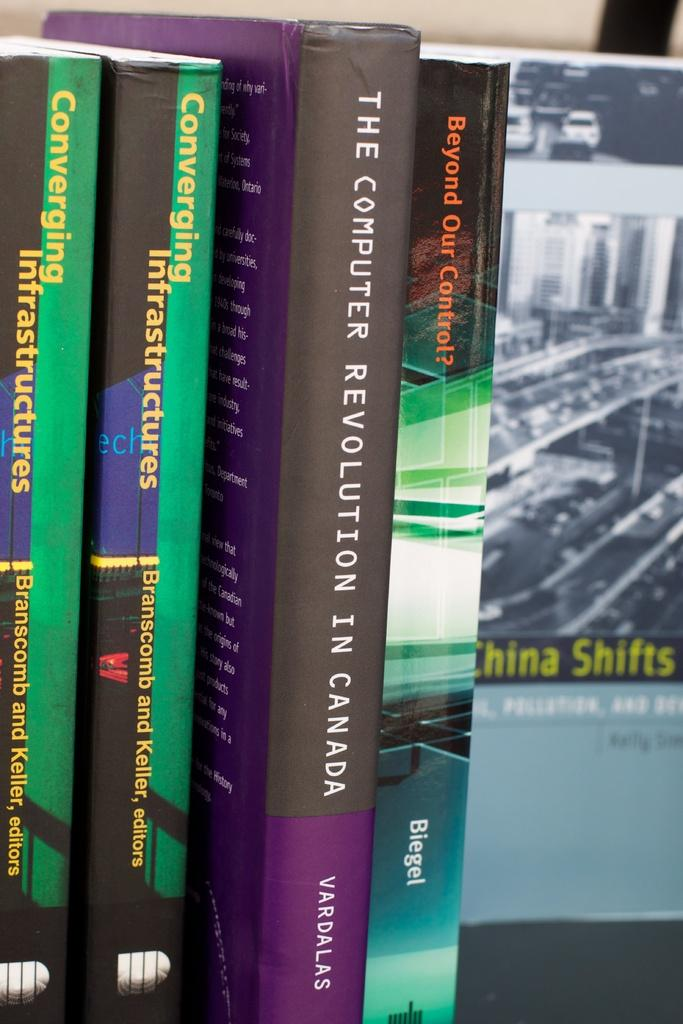<image>
Offer a succinct explanation of the picture presented. a row of books with one of them called 'the computer revolution in canada' 